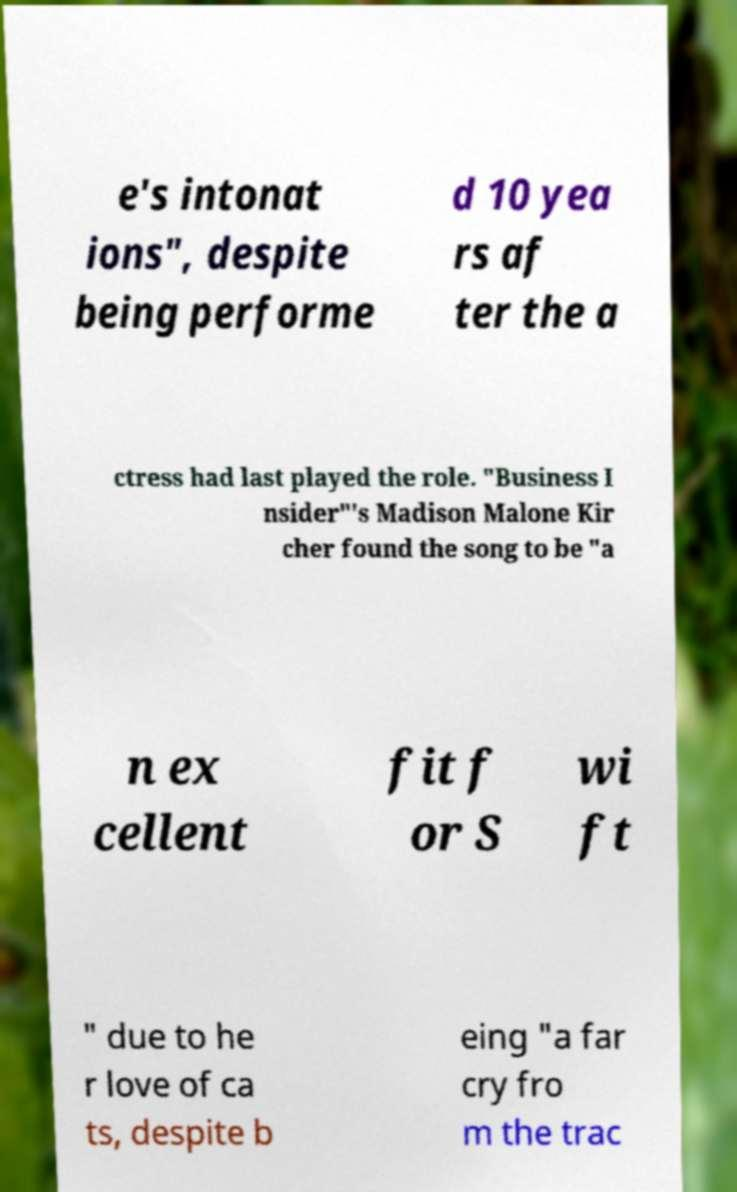Please read and relay the text visible in this image. What does it say? e's intonat ions", despite being performe d 10 yea rs af ter the a ctress had last played the role. "Business I nsider"'s Madison Malone Kir cher found the song to be "a n ex cellent fit f or S wi ft " due to he r love of ca ts, despite b eing "a far cry fro m the trac 